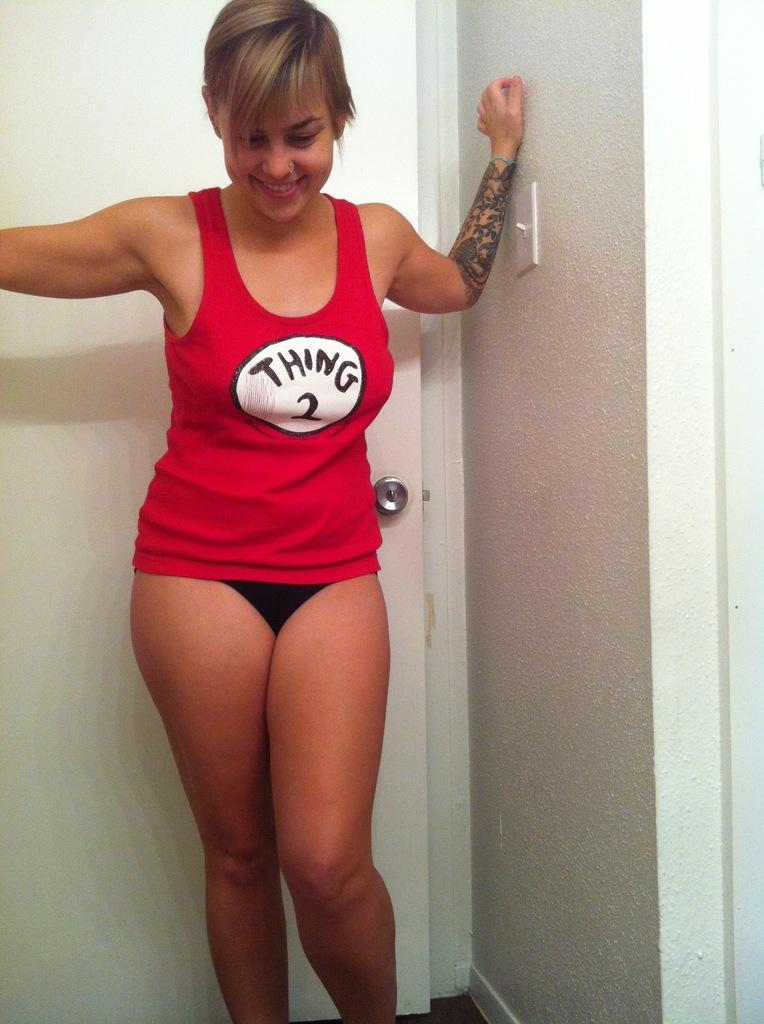<image>
Write a terse but informative summary of the picture. Thing 2 is the theme of the red shirt. 